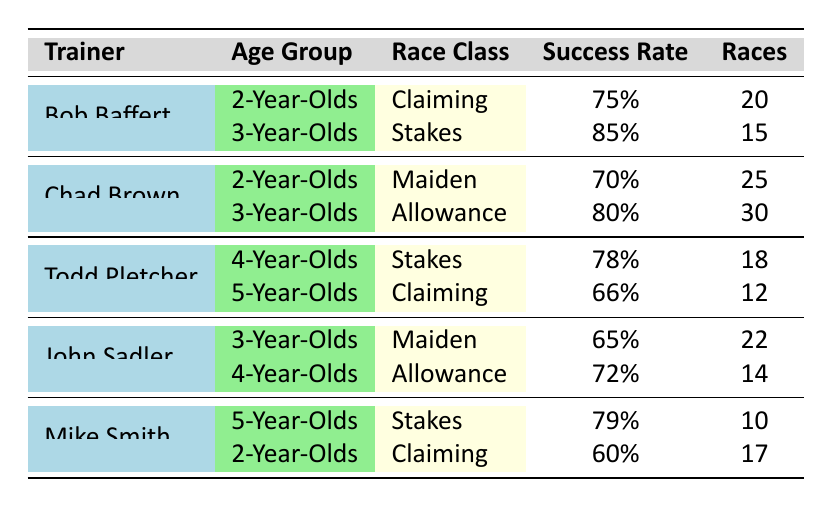What is the highest success rate among the trainers for 3-Year-Olds? Looking at the table for the success rates of 3-Year-Olds, Bob Baffert has a success rate of 85%, while Chad Brown has 80% and John Sadler has 65%. Therefore, the highest is Bob Baffert at 85%.
Answer: 85% How many races has Todd Pletcher trained for 4-Year-Olds? The table shows that Todd Pletcher has trained for 18 races with 4-Year-Olds in the Stakes race class.
Answer: 18 What is the average success rate for Chad Brown across all age groups in the table? Adding Chad Brown's success rates: 70% (2-Year-Olds) + 80% (3-Year-Olds) = 150%. There are 2 data points, so the average is 150% / 2 = 75%.
Answer: 75% Is John Sadler's success rate for 4-Year-Olds higher than Mike Smith's for 5-Year-Olds? John Sadler has a success rate of 72% for 4-Year-Olds, while Mike Smith has 79% for 5-Year-Olds. Since 72% is less than 79%, the statement is false.
Answer: No Which trainer has the lowest success rate in the table? Reviewing all success rates, Todd Pletcher has a minimum of 66% for 5-Year-Olds, while all others have higher rates. Therefore, 66% is the lowest success rate in the data.
Answer: 66% How many races did Bob Baffert train overall? Bob Baffert trained in 20 races for 2-Year-Olds and 15 for 3-Year-Olds. The total races are 20 + 15 = 35 races.
Answer: 35 Is there a trainer whose success rate for 2-Year-Olds is less than 70%? Reviewing the data, Mike Smith has a success rate of 60% for 2-Year-Olds, which is less than 70%. Thus, the answer is yes.
Answer: Yes What is the combined number of races trained by all trainers for 5-Year-Olds? From the table, Todd Pletcher has 12 races and Mike Smith has 10 races for 5-Year-Olds. The total is 12 + 10 = 22 races combined.
Answer: 22 